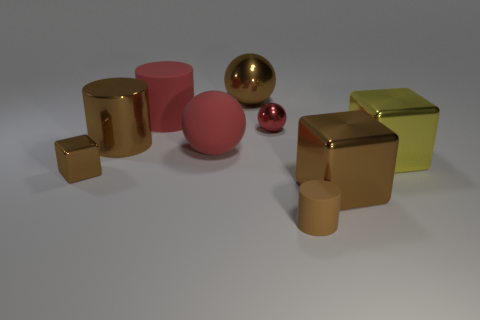What number of big balls are in front of the metal cylinder and behind the large brown shiny cylinder?
Your answer should be compact. 0. Is there any other thing that has the same size as the red matte cylinder?
Your response must be concise. Yes. Is the number of small brown metallic blocks that are behind the small red object greater than the number of large red spheres that are behind the large metal sphere?
Make the answer very short. No. What is the large brown object behind the red cylinder made of?
Keep it short and to the point. Metal. There is a tiny red thing; is its shape the same as the tiny metal thing left of the big metallic ball?
Provide a succinct answer. No. What number of brown blocks are right of the object in front of the big thing that is in front of the large yellow object?
Ensure brevity in your answer.  1. What color is the large rubber thing that is the same shape as the tiny brown matte object?
Provide a succinct answer. Red. Is there any other thing that is the same shape as the tiny red object?
Your answer should be very brief. Yes. How many balls are either small matte objects or matte objects?
Ensure brevity in your answer.  1. What shape is the small red object?
Make the answer very short. Sphere. 